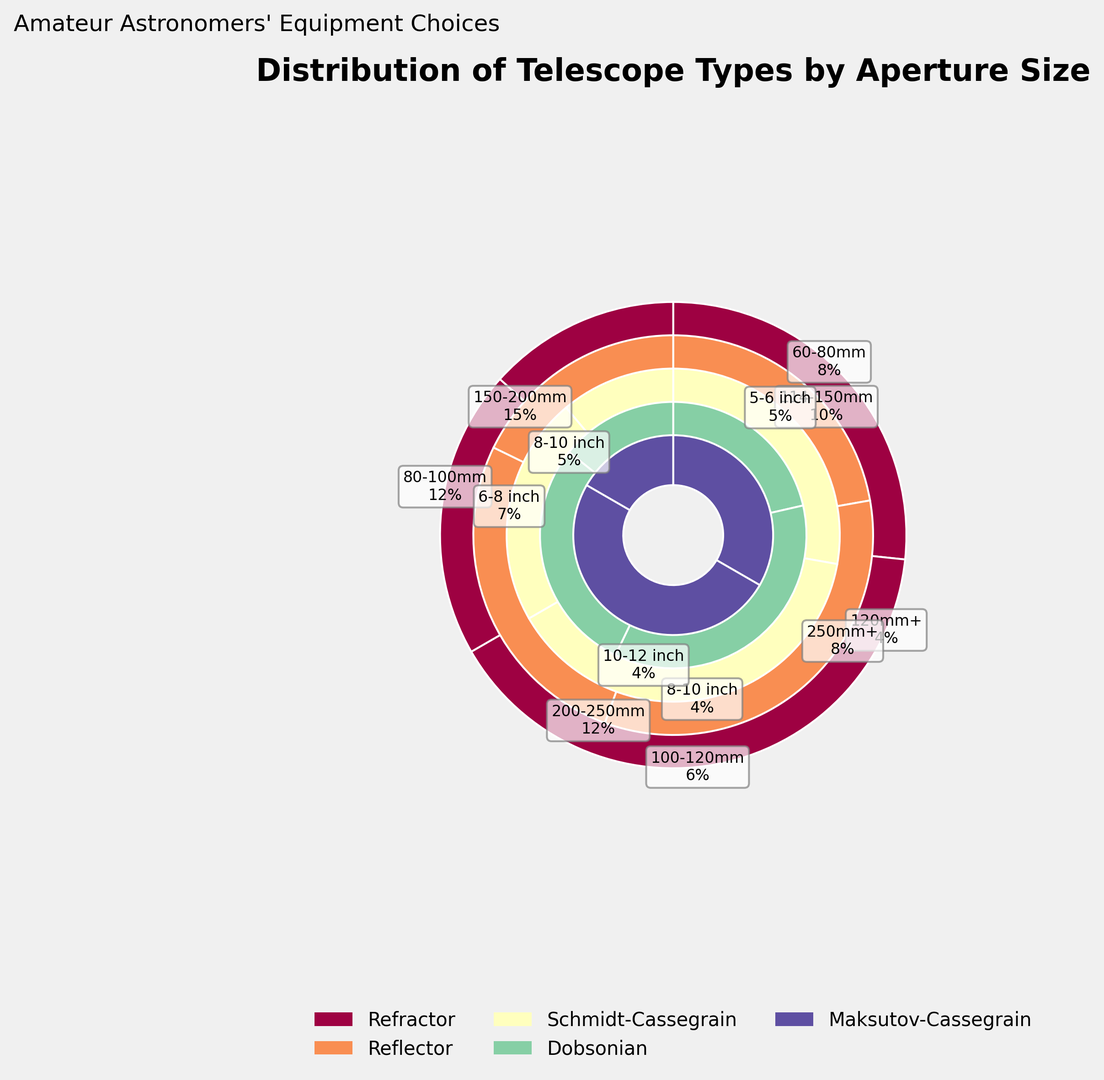Which telescope type has the highest percentage in the 80-100mm aperture size category? The figure shows different telescope types and their distribution across various aperture sizes. By looking at the 80-100mm ring, we can see the largest segment corresponds to the Refractor telescope.
Answer: Refractor What is the combined percentage of Refractor telescopes with aperture sizes between 60-120mm? The percentages for Refractor telescopes in the 60-80mm, 80-100mm, and 100-120mm categories are 8%, 12%, and 6%, respectively. Summing them up gives 8 + 12 + 6 = 26%.
Answer: 26% How does the percentage of Schmidt-Cassegrain telescopes with 10+ inch aperture compare to the percentage of Dobsonian telescopes with 12+ inch aperture? The percentage for Schmidt-Cassegrain telescopes with 10+ inch aperture is 2%, and for Dobsonian telescopes with 12+ inch aperture, it is also 2%. So, they are equal.
Answer: Equal Which type of telescope has the smallest percentage in the 127-180mm aperture size? The ring corresponding to the 127-180mm aperture size indicates multiple telescope types. The smallest wedge in this section belongs to Maksutov-Cassegrain with 1%.
Answer: Maksutov-Cassegrain For telescope types with multiple aperture categories, which one shows consistently higher percentages across these categories? Refractor and Reflector telescopes have multiple aperture categories in the figure. Comparing both, Reflector telescopes consistently show higher percentages (10%, 15%, 12%, 8%) than Refractor telescopes (8%, 12%, 6%, 4%).
Answer: Reflector What is the color of the segments representing Refractor telescopes? The Refractor telescope segments are shown using a consistent color across different aperture sizes. By visually checking the figure, the Refractor segments have a distinct color.
Answer: [Provide the observed color from the figure] What is the ratio of the percentage of Reflector telescopes with 150-200mm aperture to those with 200-250mm aperture? The percentages for Reflector telescopes with 150-200mm and 200-250mm apertures are 15% and 12%, respectively. The ratio is calculated as 15 / 12 = 1.25.
Answer: 1.25 If amateur astronomers were to choose only Schmidt-Cassegrain or Dobsonian telescopes, what would be the combined percentage of telescopes with aperture sizes of 6-8 inches? The Schmidt-Cassegrain telescopes with 6-8 inch aperture have a 7% share and Dobsonian telescopes with 6-8 inch aperture have a 3% share. Summing these values gives 7 + 3 = 10%.
Answer: 10% Which telescope type has the smallest total presence across all aperture sizes? By scanning through the entire figure, Maksutov-Cassegrain has small percentages (2%, 3%, 1%) across all aperture sizes, making it the type with the smallest total presence.
Answer: Maksutov-Cassegrain 